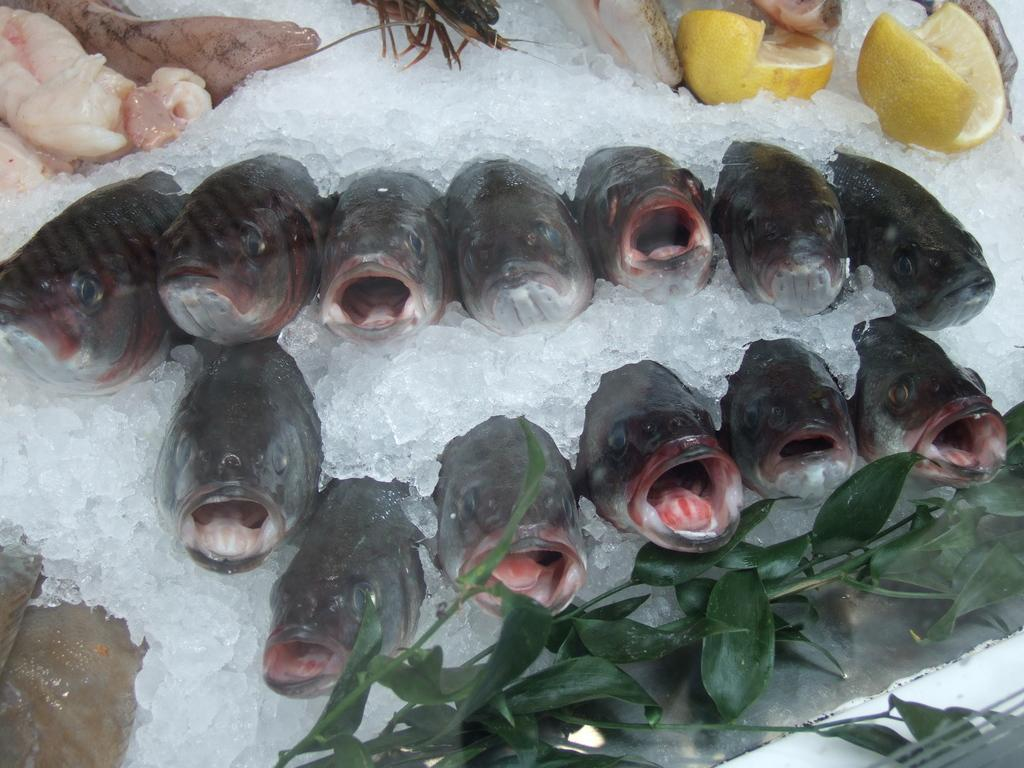What type of animals can be seen in the image? There are many fishes in the ice. What fruit is present in the image? There are lemons on the ice. What else can be seen on the ice besides fishes and lemons? There are stems on the ice, as well as other unspecified things. What type of veil is draped over the fishes in the image? There is no veil present in the image; it only features fishes, lemons, stems, and unspecified things on the ice. 